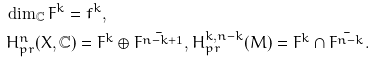Convert formula to latex. <formula><loc_0><loc_0><loc_500><loc_500>& \dim _ { \mathbb { C } } F ^ { k } = f ^ { k } , \\ & H ^ { n } _ { p r } ( X , { \mathbb { C } } ) = F ^ { k } \oplus \bar { F ^ { n - k + 1 } } , H _ { p r } ^ { k , n - k } ( M ) = F ^ { k } \cap \bar { F ^ { n - k } } .</formula> 